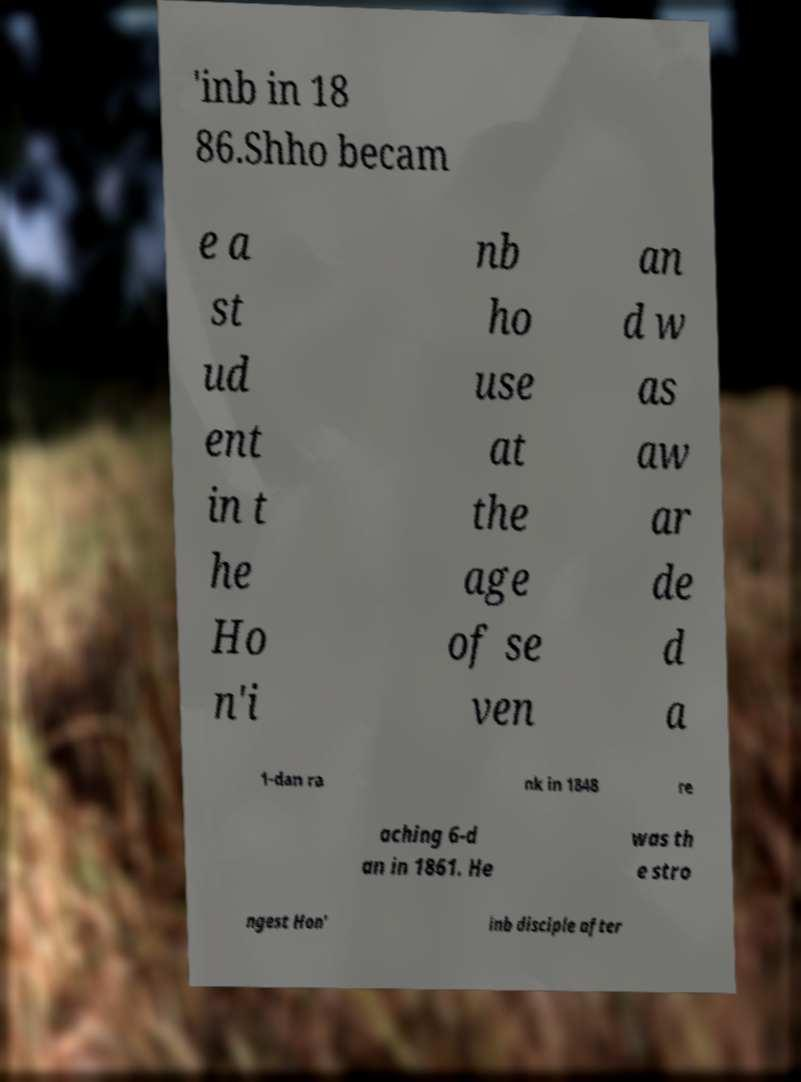I need the written content from this picture converted into text. Can you do that? 'inb in 18 86.Shho becam e a st ud ent in t he Ho n'i nb ho use at the age of se ven an d w as aw ar de d a 1-dan ra nk in 1848 re aching 6-d an in 1861. He was th e stro ngest Hon' inb disciple after 